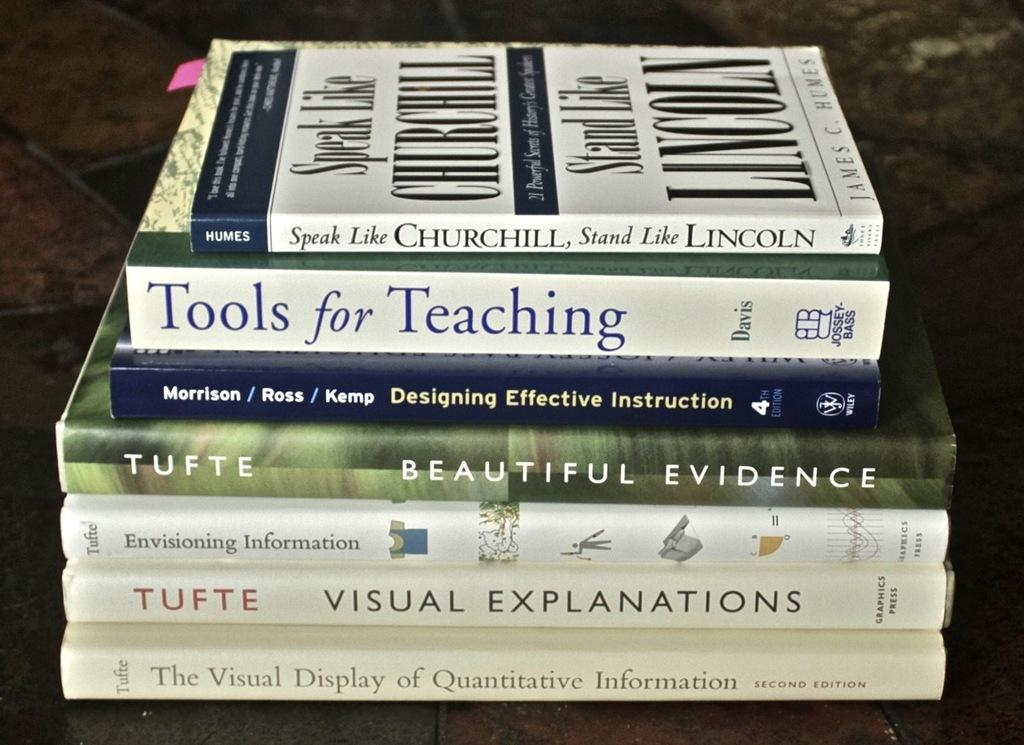<image>
Share a concise interpretation of the image provided. a tools for teaching book that is below a Lincoln book 